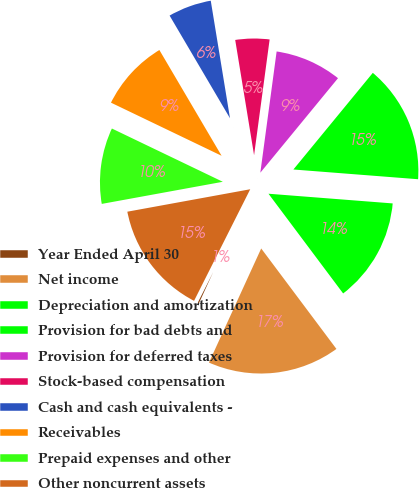Convert chart to OTSL. <chart><loc_0><loc_0><loc_500><loc_500><pie_chart><fcel>Year Ended April 30<fcel>Net income<fcel>Depreciation and amortization<fcel>Provision for bad debts and<fcel>Provision for deferred taxes<fcel>Stock-based compensation<fcel>Cash and cash equivalents -<fcel>Receivables<fcel>Prepaid expenses and other<fcel>Other noncurrent assets<nl><fcel>0.59%<fcel>17.06%<fcel>13.53%<fcel>15.29%<fcel>8.82%<fcel>4.71%<fcel>5.88%<fcel>9.41%<fcel>10.0%<fcel>14.7%<nl></chart> 